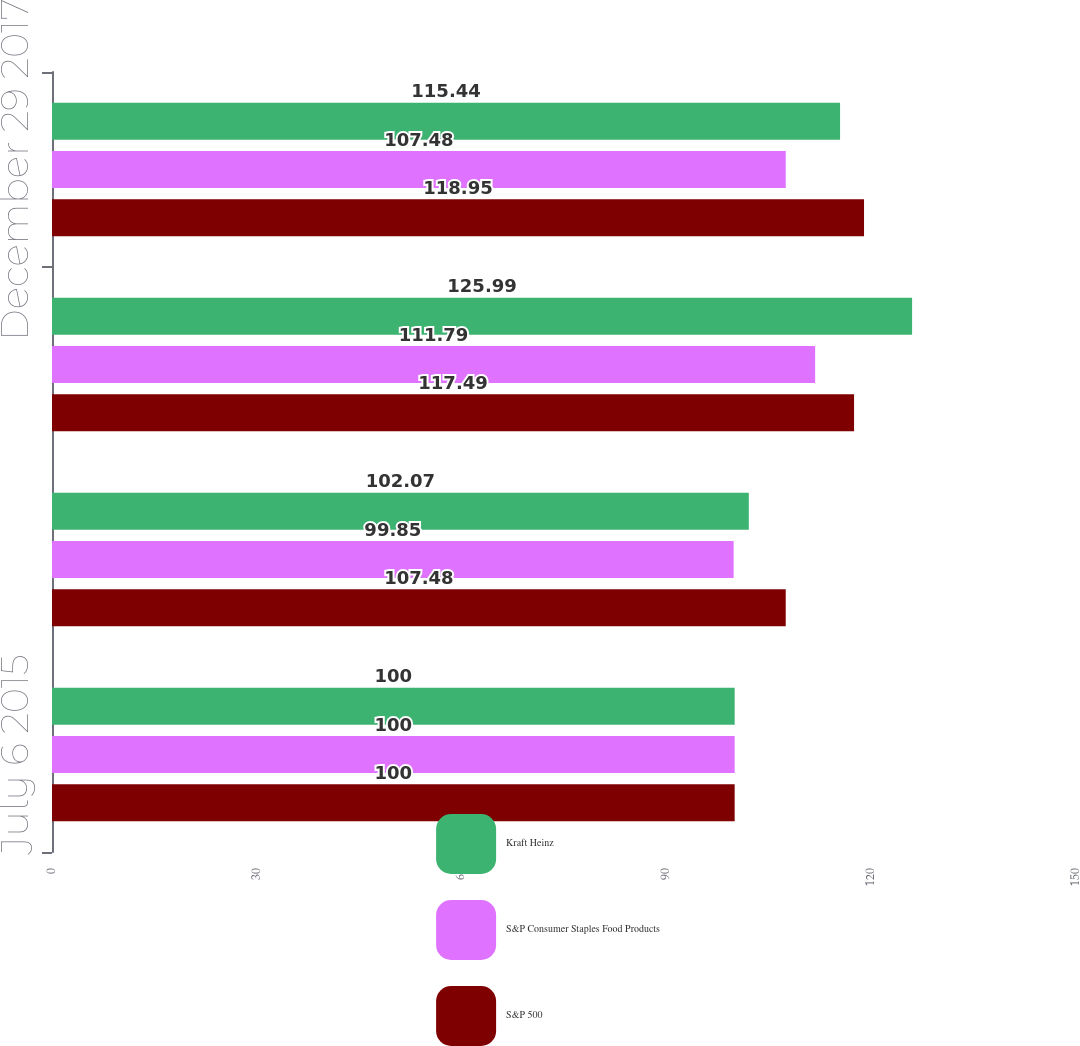Convert chart to OTSL. <chart><loc_0><loc_0><loc_500><loc_500><stacked_bar_chart><ecel><fcel>July 6 2015<fcel>December 31 2015<fcel>December 30 2016<fcel>December 29 2017<nl><fcel>Kraft Heinz<fcel>100<fcel>102.07<fcel>125.99<fcel>115.44<nl><fcel>S&P Consumer Staples Food Products<fcel>100<fcel>99.85<fcel>111.79<fcel>107.48<nl><fcel>S&P 500<fcel>100<fcel>107.48<fcel>117.49<fcel>118.95<nl></chart> 